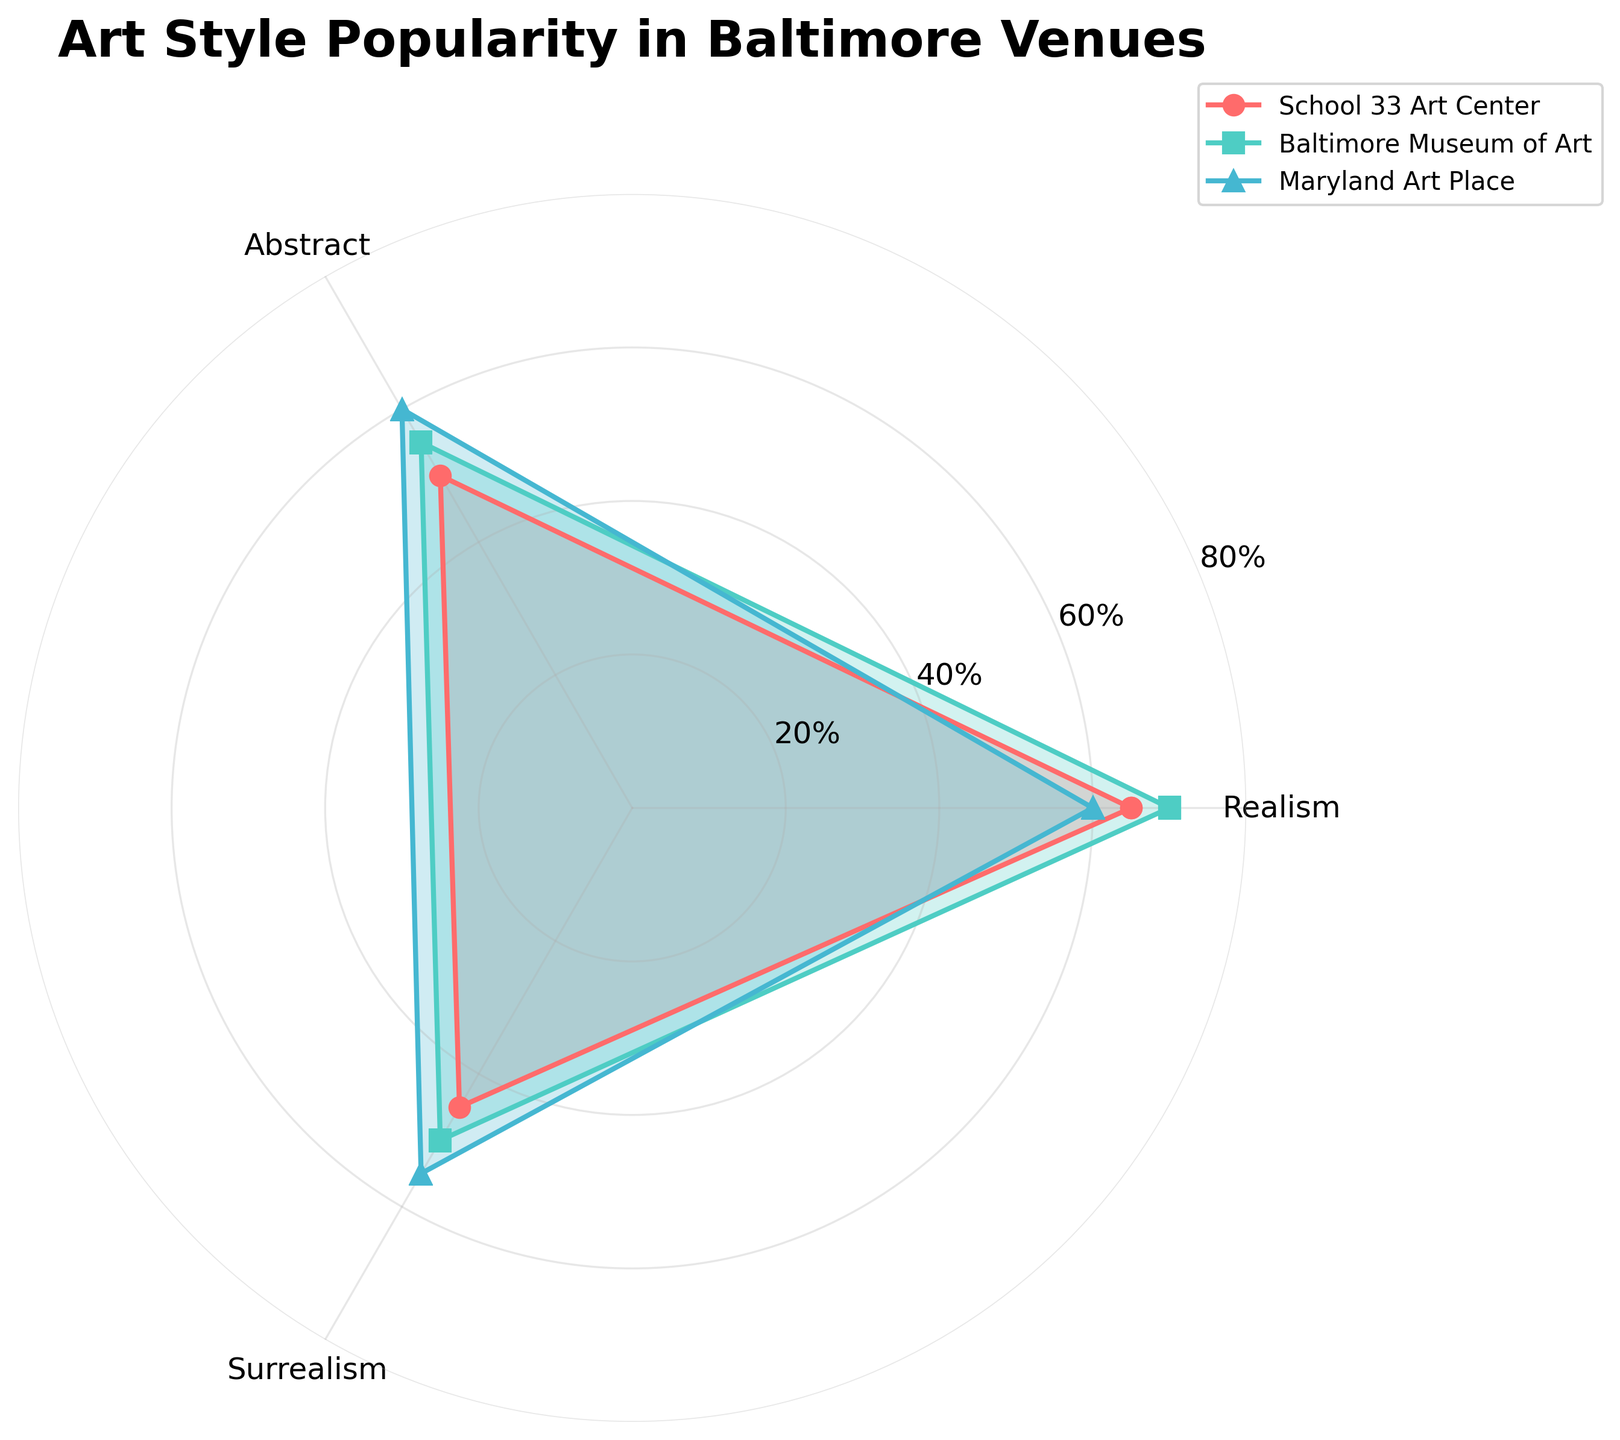What are the three art styles shown in the radar chart? The radar chart lists three different art styles in its categories. These art styles are positioned around the radar chart and are labeled accordingly.
Answer: Realism, Abstract, Surrealism Which venue has the highest popularity for Surrealism? Looking at the values for Surrealism across all venues, identify the highest value and the corresponding venue.
Answer: Current Space How many venues are plotted on the radar chart? Count the number of different lines (with marker symbols), each representing a venue around the radar chart.
Answer: 3 What is the average popularity of Abstract art across all venues shown? Add the popularity values for Abstract art from all three venues and divide by the number of venues. The calculation is (50 + 55 + 60) / 3.
Answer: 55 Which venue has the smallest range of popularity among the three art styles? Calculate the range (difference between highest and lowest values) of each venue and identify the smallest range. For School 33 Art Center, the range is 65 - 45 = 20. For Baltimore Museum of Art, it's 70 - 50 = 20. For Maryland Art Place, it's 60 - 55 = 5. Maryland Art Place has the smallest range.
Answer: Maryland Art Place How does the popularity of Realism at the Baltimore Museum of Art compare to School 33 Art Center? Compare the values of Realism for both venues. The value for Baltimore Museum of Art is 70 and for School 33 Art Center is 65.
Answer: Baltimore Museum of Art is higher by 5 (70 vs 65) What is the overall trend in the popularity of Surrealism across the venues? Examine the values for Surrealism across the venues and assess if there is an increasing, decreasing, or mixed trend.
Answer: Mixed Which art style has the highest median popularity across the venues? List the popularity values of each art style across the venues and find the median value for each. For Realism: [65, 70, 75], for Abstract: [50, 55, 60], and for Surrealism: [45, 50, 60]. The median values are 70, 55, and 50 respectively.
Answer: Realism What is the difference in Realism popularity between Current Space and Maryland Art Place? Subtract the Realism value of Maryland Art Place from Current Space. The calculation is 75 - 60.
Answer: 15 Which venue has the most equal popularity distribution across the three art styles? Check which venue has the lowest range (difference between maximum and minimum values) among the three art styles. As previously calculated, Maryland Art Place has the smallest range of 5.
Answer: Maryland Art Place 